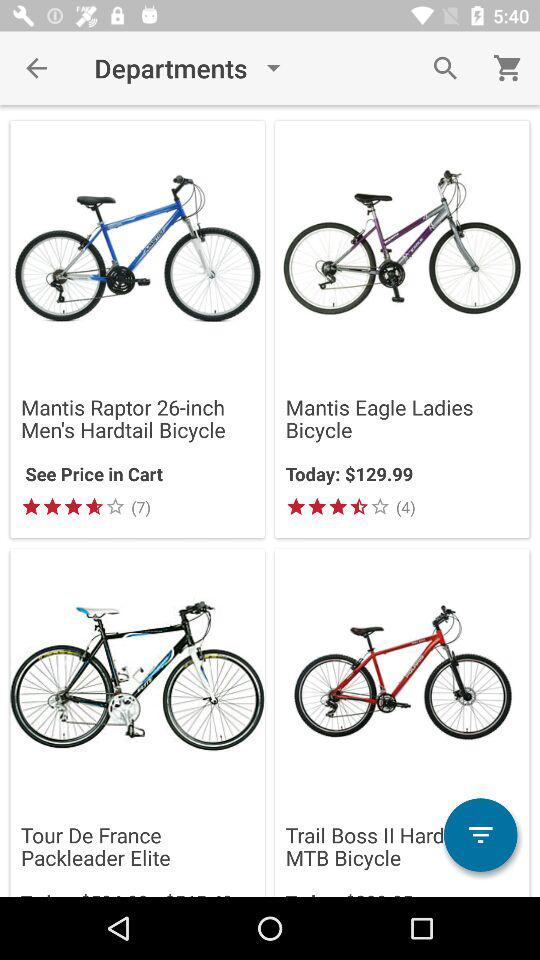Where can we see the price of the Mantis Raptor 26-inch? You can see the price of the Mantis Raptor 26-inch in the cart. 